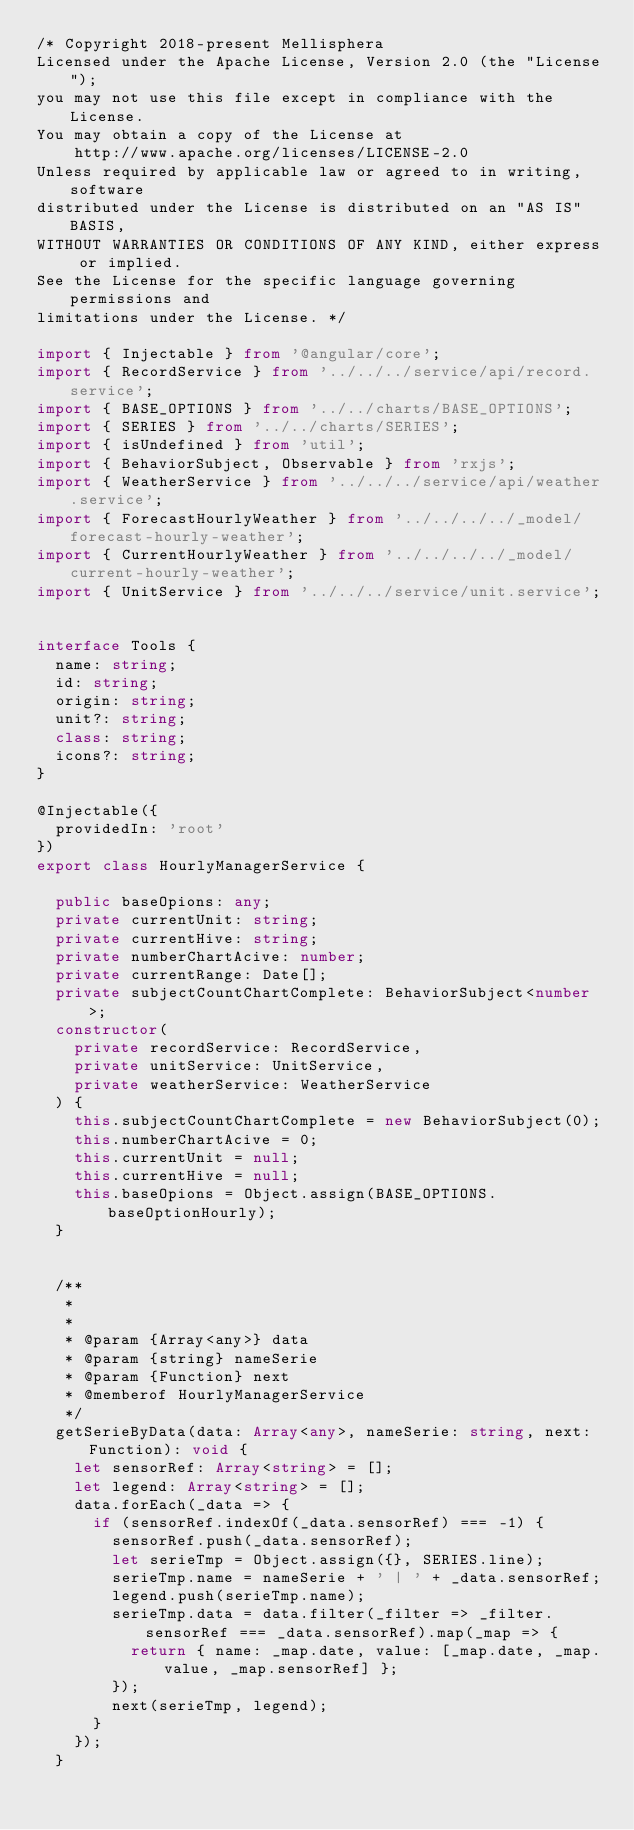<code> <loc_0><loc_0><loc_500><loc_500><_TypeScript_>/* Copyright 2018-present Mellisphera
Licensed under the Apache License, Version 2.0 (the "License");
you may not use this file except in compliance with the License.
You may obtain a copy of the License at
    http://www.apache.org/licenses/LICENSE-2.0
Unless required by applicable law or agreed to in writing, software
distributed under the License is distributed on an "AS IS" BASIS,
WITHOUT WARRANTIES OR CONDITIONS OF ANY KIND, either express or implied.
See the License for the specific language governing permissions and
limitations under the License. */

import { Injectable } from '@angular/core';
import { RecordService } from '../../../service/api/record.service';
import { BASE_OPTIONS } from '../../charts/BASE_OPTIONS';
import { SERIES } from '../../charts/SERIES';
import { isUndefined } from 'util';
import { BehaviorSubject, Observable } from 'rxjs';
import { WeatherService } from '../../../service/api/weather.service';
import { ForecastHourlyWeather } from '../../../../_model/forecast-hourly-weather';
import { CurrentHourlyWeather } from '../../../../_model/current-hourly-weather';
import { UnitService } from '../../../service/unit.service';


interface Tools {
  name: string;
  id: string;
  origin: string;
  unit?: string;
  class: string;
  icons?: string;
}

@Injectable({
  providedIn: 'root'
})
export class HourlyManagerService {

  public baseOpions: any;
  private currentUnit: string;
  private currentHive: string;
  private numberChartAcive: number;
  private currentRange: Date[];
  private subjectCountChartComplete: BehaviorSubject<number>;
  constructor(
    private recordService: RecordService,
    private unitService: UnitService,
    private weatherService: WeatherService
  ) {
    this.subjectCountChartComplete = new BehaviorSubject(0);
    this.numberChartAcive = 0;
    this.currentUnit = null;
    this.currentHive = null;
    this.baseOpions = Object.assign(BASE_OPTIONS.baseOptionHourly);
  }


  /**
   *
   *
   * @param {Array<any>} data
   * @param {string} nameSerie
   * @param {Function} next
   * @memberof HourlyManagerService
   */
  getSerieByData(data: Array<any>, nameSerie: string, next: Function): void {
    let sensorRef: Array<string> = [];
    let legend: Array<string> = [];
    data.forEach(_data => {
      if (sensorRef.indexOf(_data.sensorRef) === -1) {
        sensorRef.push(_data.sensorRef);
        let serieTmp = Object.assign({}, SERIES.line);
        serieTmp.name = nameSerie + ' | ' + _data.sensorRef;
        legend.push(serieTmp.name);
        serieTmp.data = data.filter(_filter => _filter.sensorRef === _data.sensorRef).map(_map => {
          return { name: _map.date, value: [_map.date, _map.value, _map.sensorRef] };
        });
        next(serieTmp, legend);
      }
    });
  }</code> 